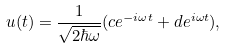<formula> <loc_0><loc_0><loc_500><loc_500>u ( t ) = \frac { 1 } { \sqrt { 2 \hbar { \omega } } } ( c e ^ { - i \omega t } + d e ^ { i \omega t } ) ,</formula> 